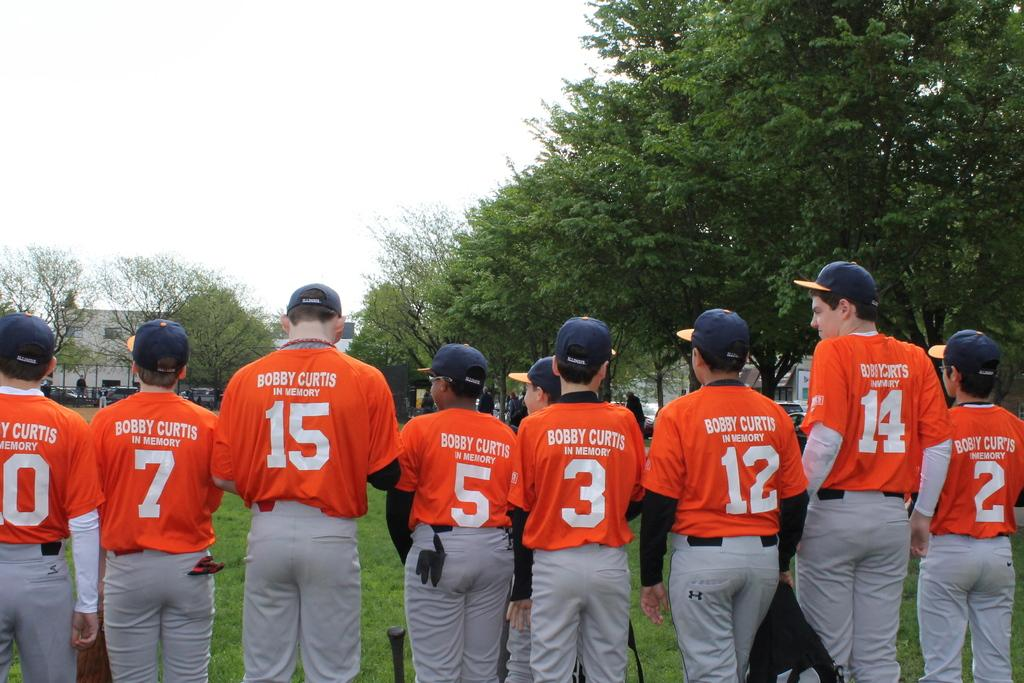<image>
Render a clear and concise summary of the photo. Several baseball players wear orange jerseys that are in memory of Bobby Curtis. 